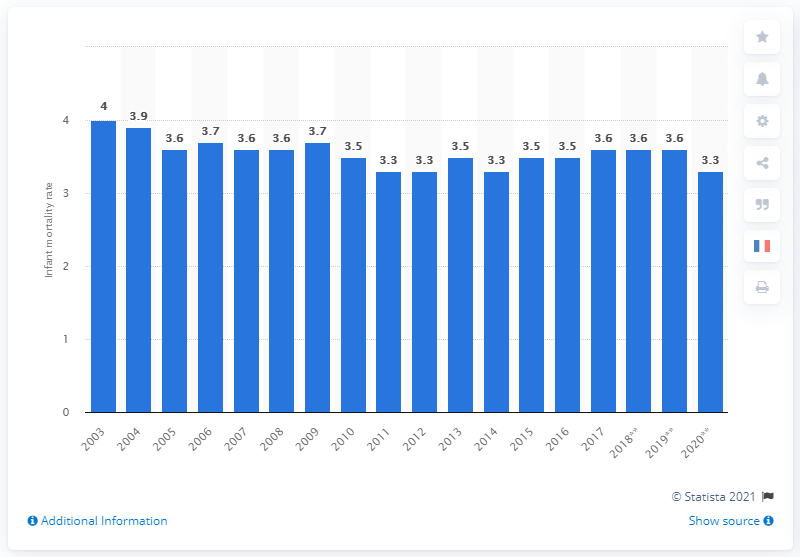Mention a couple of crucial points in this snapshot. The lowest infant mortality rate in France between 2011 and 2020 was 3.3 per 1,000 live births. In the year 2003, infant mortality was particularly low in France. 